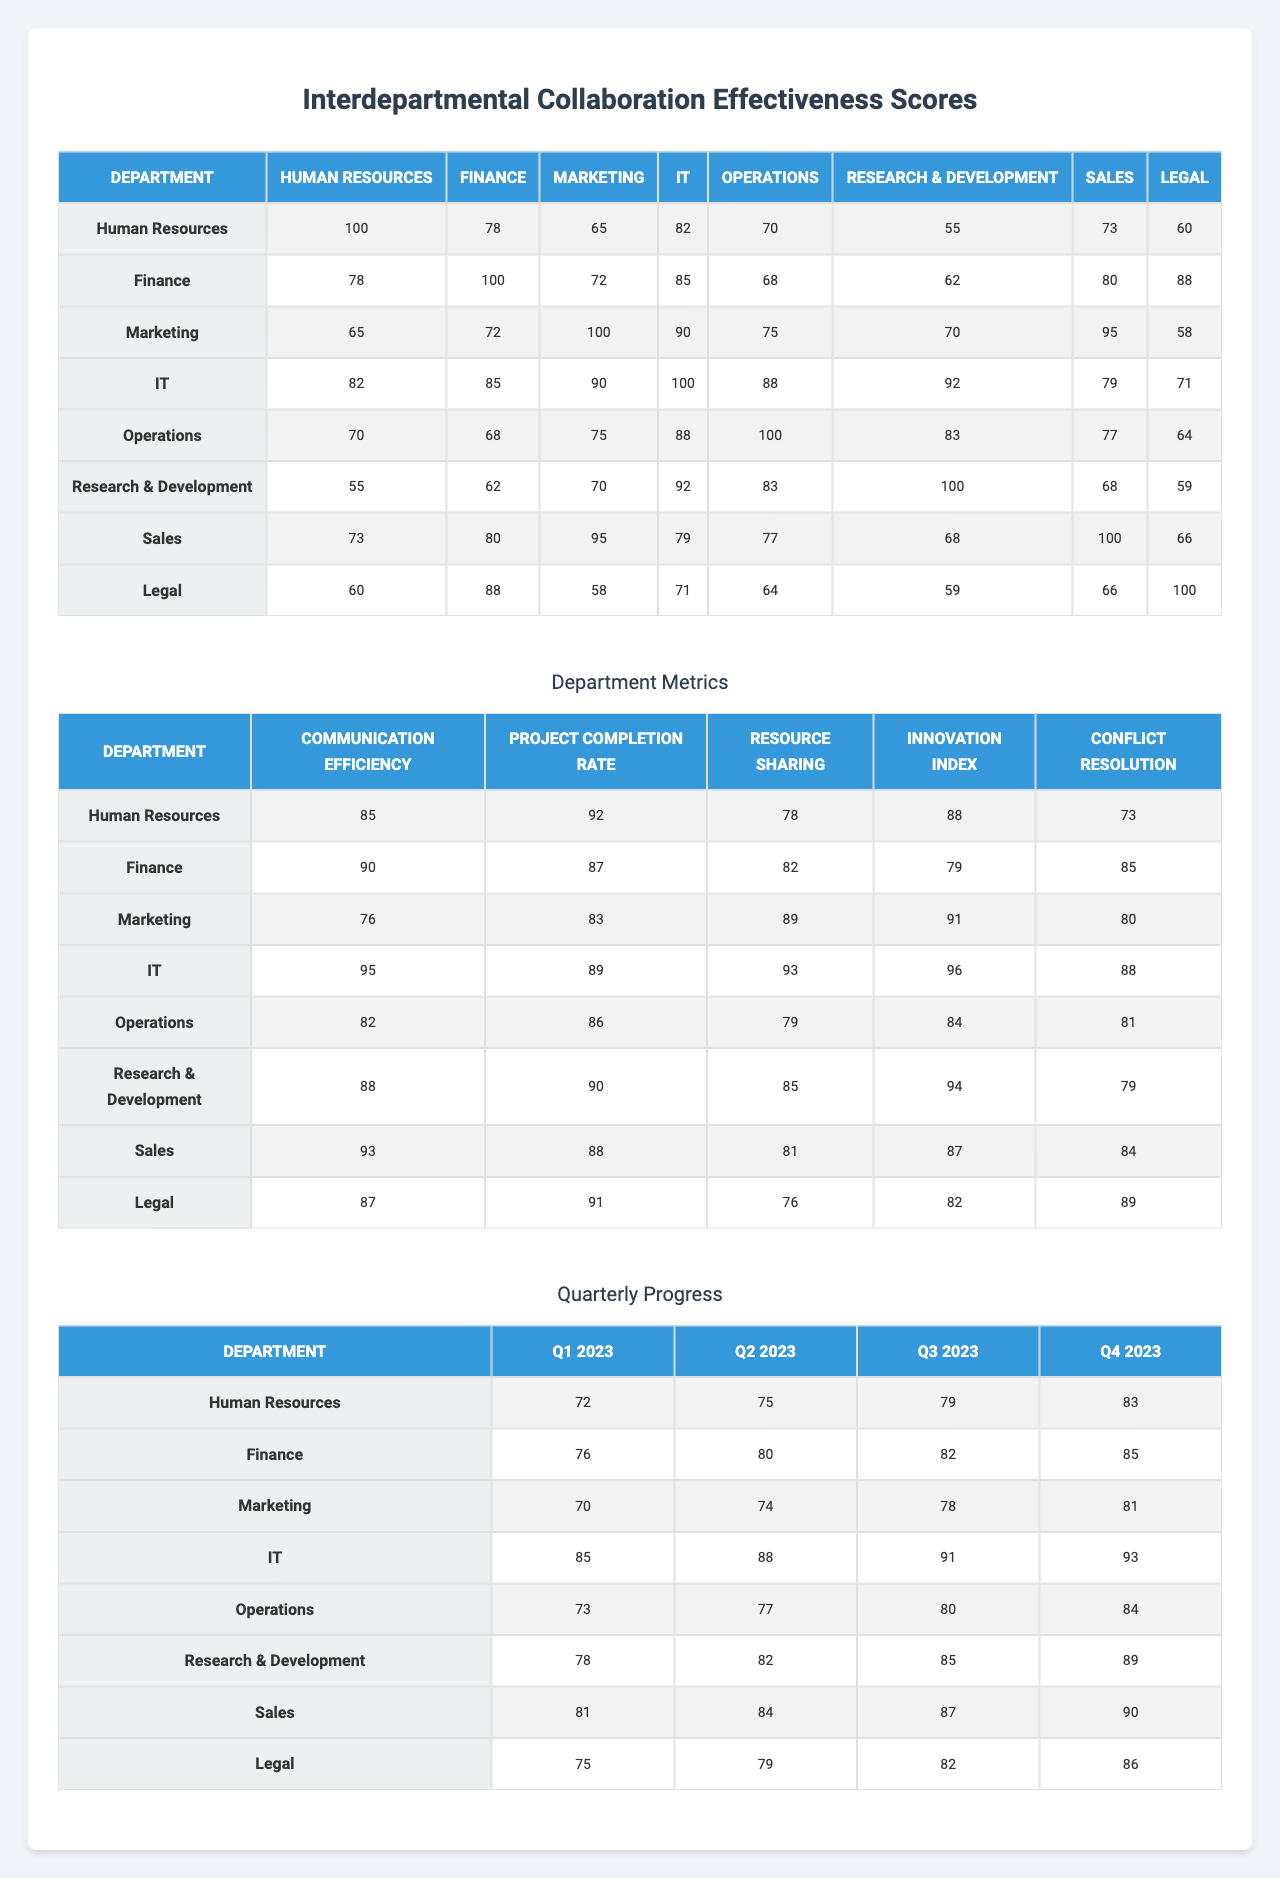What is the highest collaboration score between Marketing and Sales? Looking at the collaboration scores of Marketing and Sales, the score is 95. Therefore, that is the highest collaboration score between the two departments.
Answer: 95 What is the average collaboration score of the IT department? The collaboration scores for IT are [82, 85, 90, 100, 88, 92, 79, 71]. Adding them up gives 82 + 85 + 90 + 100 + 88 + 92 + 79 + 71 =  707. Dividing by the number of departments, which is 8, we get an average of 707 / 8 = 88.375, which we can round to 88.
Answer: 88 Which department has the lowest resource sharing metric score? The resource sharing metric scores for each department are: HR - 78, Finance - 82, Marketing - 89, IT - 93, Operations - 79, R&D - 85, Sales - 81, Legal - 76. The lowest score is 76, which belongs to the Legal department.
Answer: Legal Did the Operations department have a score higher than 80 in the quarterly progress during Q2 2023? The score for Operations in Q2 2023 is 77. Since 77 is lower than 80, the answer is no.
Answer: No What is the total collaboration score when adding the scores of HR with IT, Finance with Marketing, and Sales with Legal? The pairs to consider are HR (100) + IT (82) = 182, Finance (78) + Marketing (72) = 150, and Sales (95) + Legal (88) = 183. Adding these results together gives 182 + 150 + 183 = 515.
Answer: 515 What is the difference in the highest and lowest project completion rates across all departments? The highest project completion rate is 90 from the IT department, while the lowest is 72 from HR. The difference is 90 - 72 = 18.
Answer: 18 Which department made the most progress in Q1 2023? Looking at Q1 2023, the scores are HR - 72, Finance - 76, Marketing - 70, IT - 85, Operations - 73, R&D - 78, Sales - 81, and Legal - 75. IT has the highest score of 85.
Answer: IT If we consider the average quarterly scores for the Finance department, is it above or below 80? The quarterly scores for Finance are [76, 80, 82, 85]. The average is (76 + 80 + 82 + 85) / 4 = 323 / 4 = 80.75. Since 80.75 is above 80, the answer is yes.
Answer: Yes Which department collaborates the best with Research & Development based on the collaboration effectiveness scores? R&D scored collaboration scores with all departments, the highest score is with Marketing at 95.
Answer: Marketing What are the lowest and highest scores of the 'Conflict Resolution' metric across all departments? The 'Conflict Resolution' metric scores are: HR - 73, Finance - 85, Marketing - 70, IT - 88, Operations - 81, R&D - 79, Sales - 84, Legal - 89. The lowest score is 70 (Marketing) and the highest is 89 (Legal).
Answer: 70 and 89 